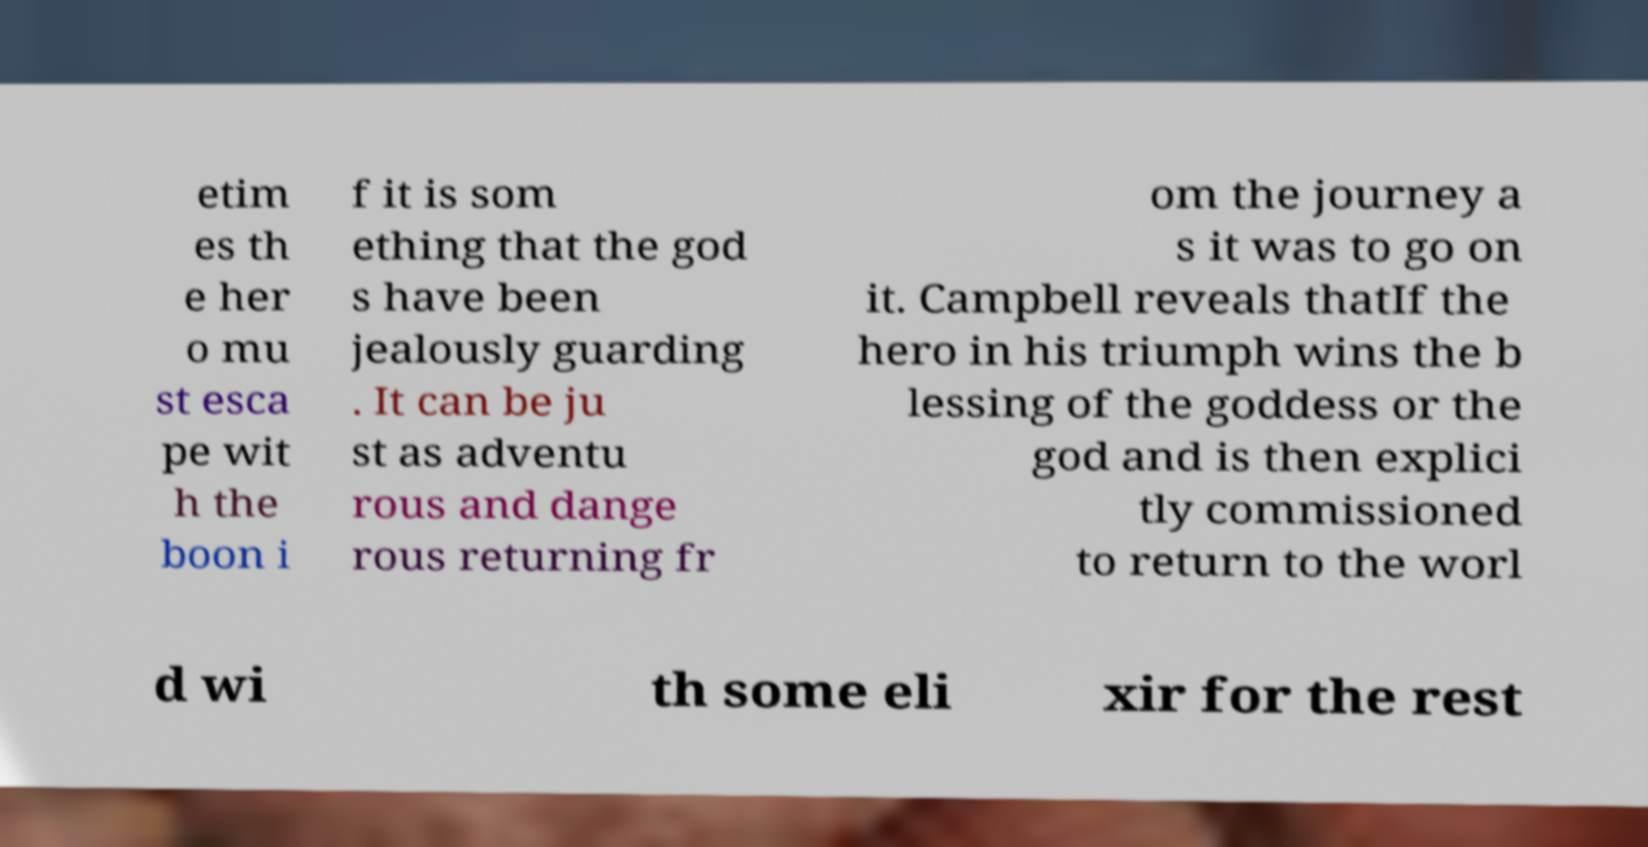Please read and relay the text visible in this image. What does it say? etim es th e her o mu st esca pe wit h the boon i f it is som ething that the god s have been jealously guarding . It can be ju st as adventu rous and dange rous returning fr om the journey a s it was to go on it. Campbell reveals thatIf the hero in his triumph wins the b lessing of the goddess or the god and is then explici tly commissioned to return to the worl d wi th some eli xir for the rest 